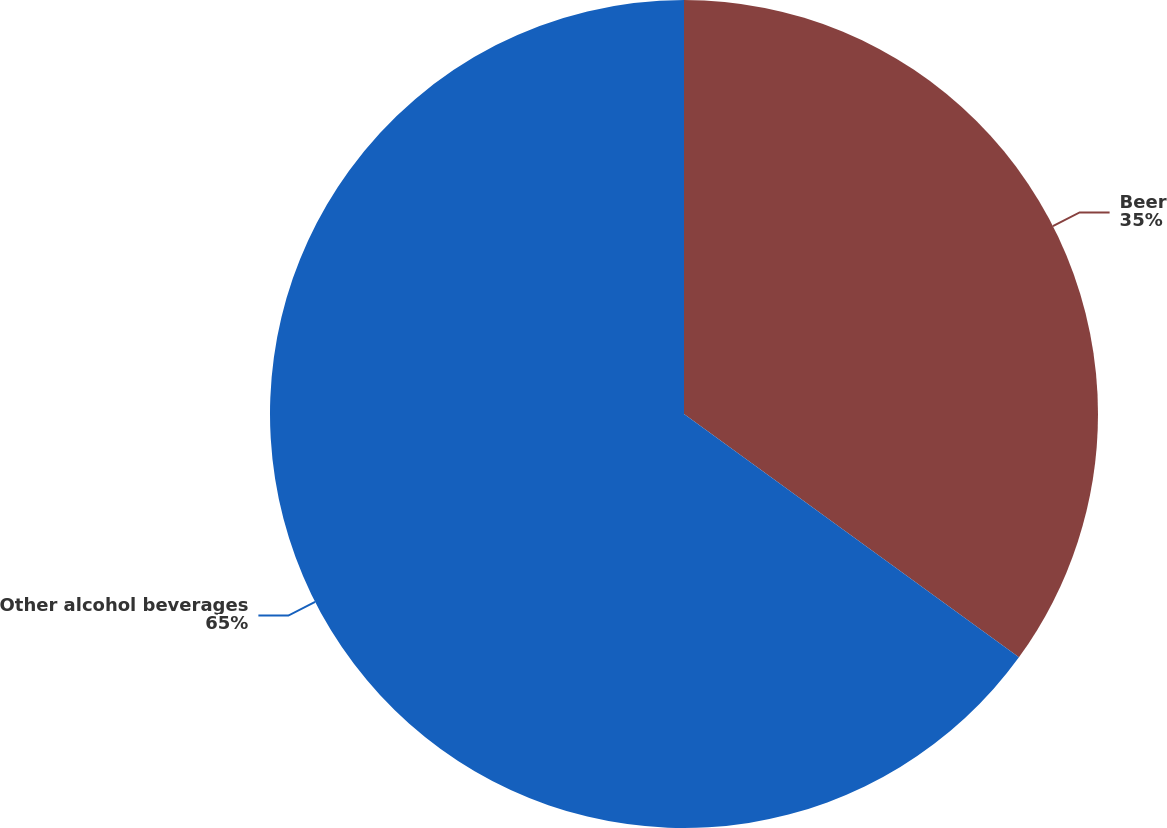<chart> <loc_0><loc_0><loc_500><loc_500><pie_chart><fcel>Beer<fcel>Other alcohol beverages<nl><fcel>35.0%<fcel>65.0%<nl></chart> 